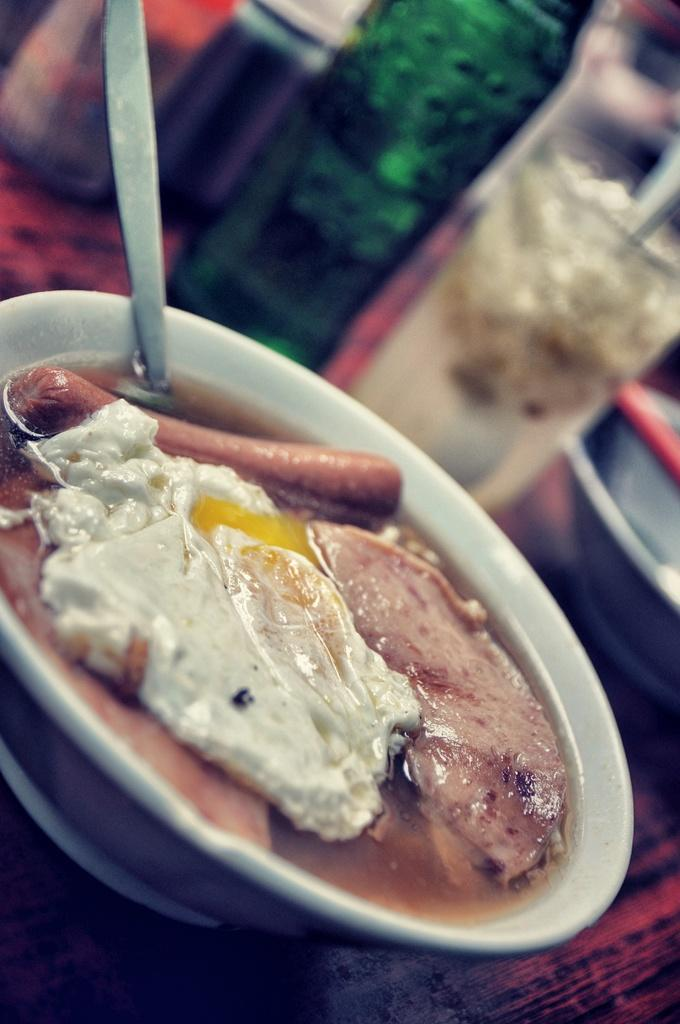What is the main object on the wooden surface in the image? There is a bowl on a wooden surface in the image. What is inside the bowl? There is a food item in the bowl. What utensil is present in the bowl? There is a spoon in the bowl. Can you describe the background of the image? The background appears blurry. What can be seen in the background besides the blurry appearance? There are bottles and glass in the background. How many women are present in the image? There are no women present in the image. Can you describe the rabbit in the image? There is no rabbit present in the image. 